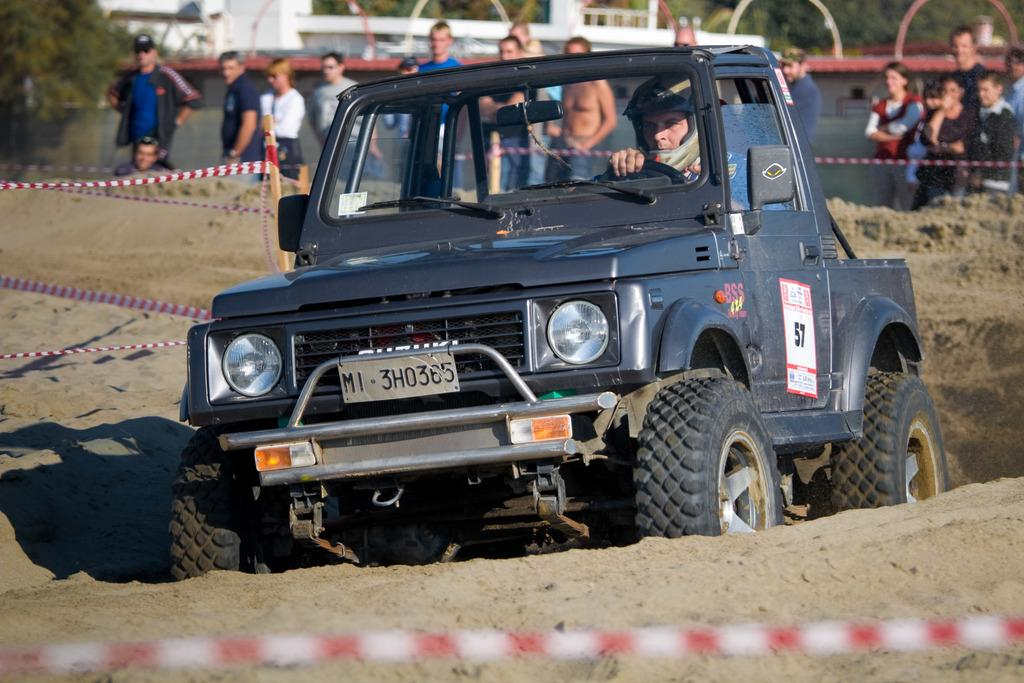What is the main subject in the center of the image? There is a jeep in the center of the image. Where are the people located in the image? The people are at the top side of the image. What type of vegetation can be seen in the top left side of the image? There are trees in the top left side of the image. What type of grass is being used to treat a sore throat in the image? There is no grass or mention of a sore throat in the image. 